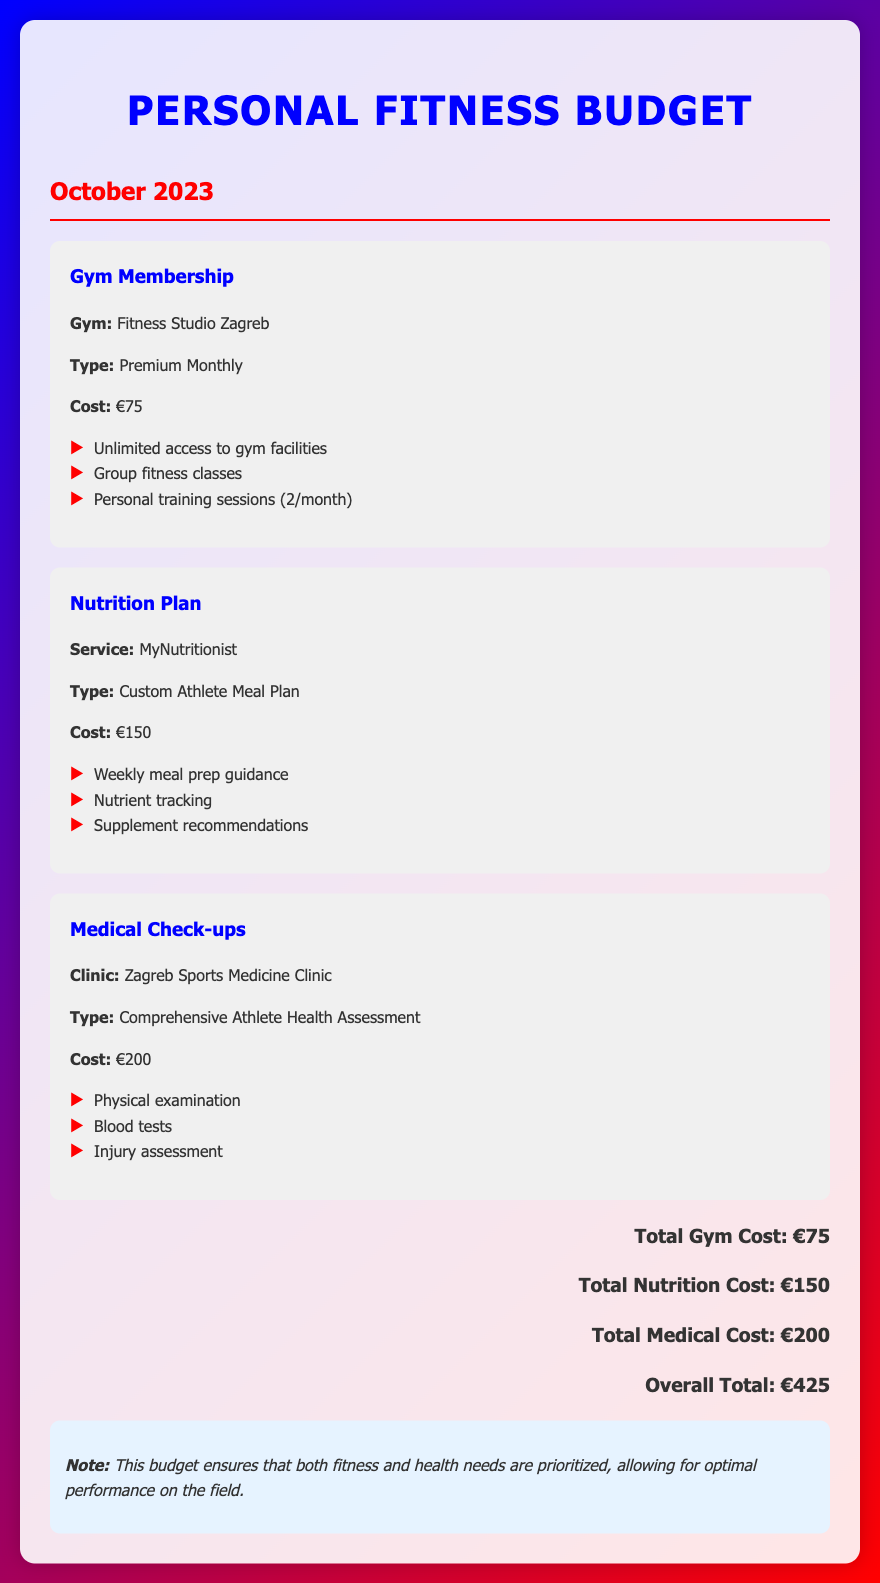What is the gym membership cost? The gym membership cost is explicitly stated in the document as €75.
Answer: €75 What type of nutrition plan is offered? The document specifies the nutrition plan type as a Custom Athlete Meal Plan.
Answer: Custom Athlete Meal Plan How much total does the medical check-up cost? The medical check-up total cost provided in the document is €200.
Answer: €200 What clinic is mentioned for medical check-ups? The document lists the Zagreb Sports Medicine Clinic as the clinic for medical check-ups.
Answer: Zagreb Sports Medicine Clinic What services does the nutrition plan include? The nutrition plan includes weekly meal prep guidance, nutrient tracking, and supplement recommendations.
Answer: Weekly meal prep guidance, nutrient tracking, supplement recommendations How many personal training sessions are included with the gym membership? The document indicates that there are two personal training sessions included per month.
Answer: 2 What is the overall total for all expenses? The overall total is calculated in the document and amounts to €425.
Answer: €425 Which gym is listed in the budget? The gym mentioned in the budget document is Fitness Studio Zagreb.
Answer: Fitness Studio Zagreb What type of assessment is included in the medical check-up? The medical check-up includes a Comprehensive Athlete Health Assessment.
Answer: Comprehensive Athlete Health Assessment 